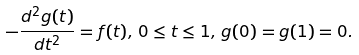Convert formula to latex. <formula><loc_0><loc_0><loc_500><loc_500>- \frac { d ^ { 2 } g ( t ) } { d t ^ { 2 } } = f ( t ) , \, 0 \leq t \leq 1 , \, g ( 0 ) = g ( 1 ) = 0 .</formula> 